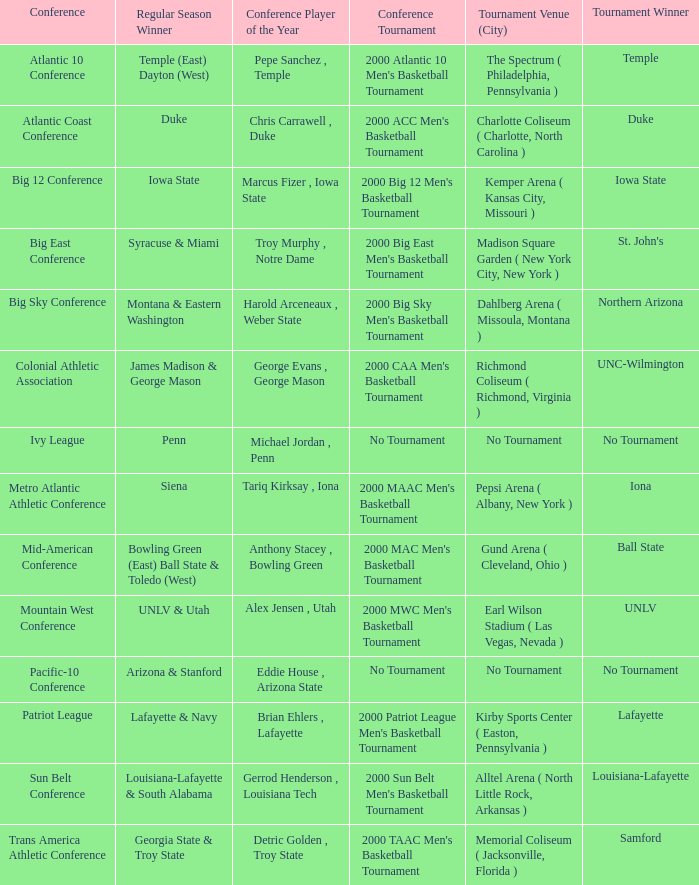Who is the conference Player of the Year in the conference where Lafayette won the tournament? Brian Ehlers , Lafayette. 